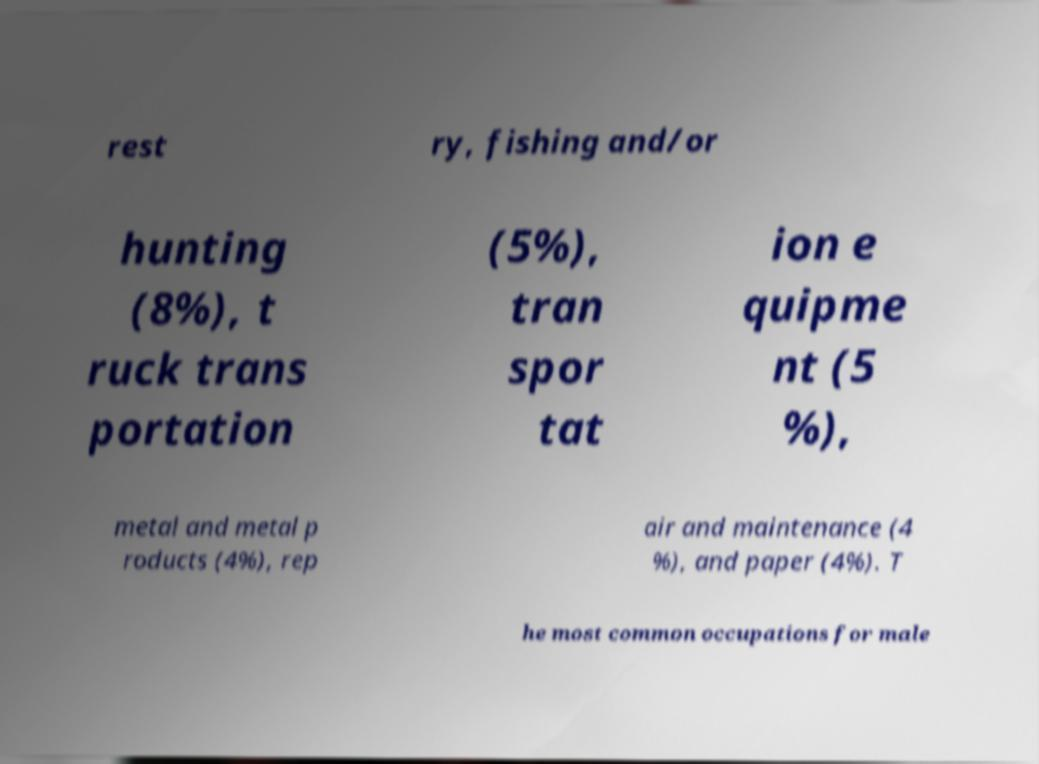Can you accurately transcribe the text from the provided image for me? rest ry, fishing and/or hunting (8%), t ruck trans portation (5%), tran spor tat ion e quipme nt (5 %), metal and metal p roducts (4%), rep air and maintenance (4 %), and paper (4%). T he most common occupations for male 